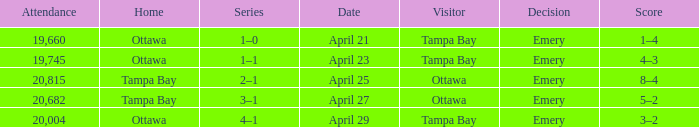What is the date of the game when attendance is more than 20,682? April 25. 